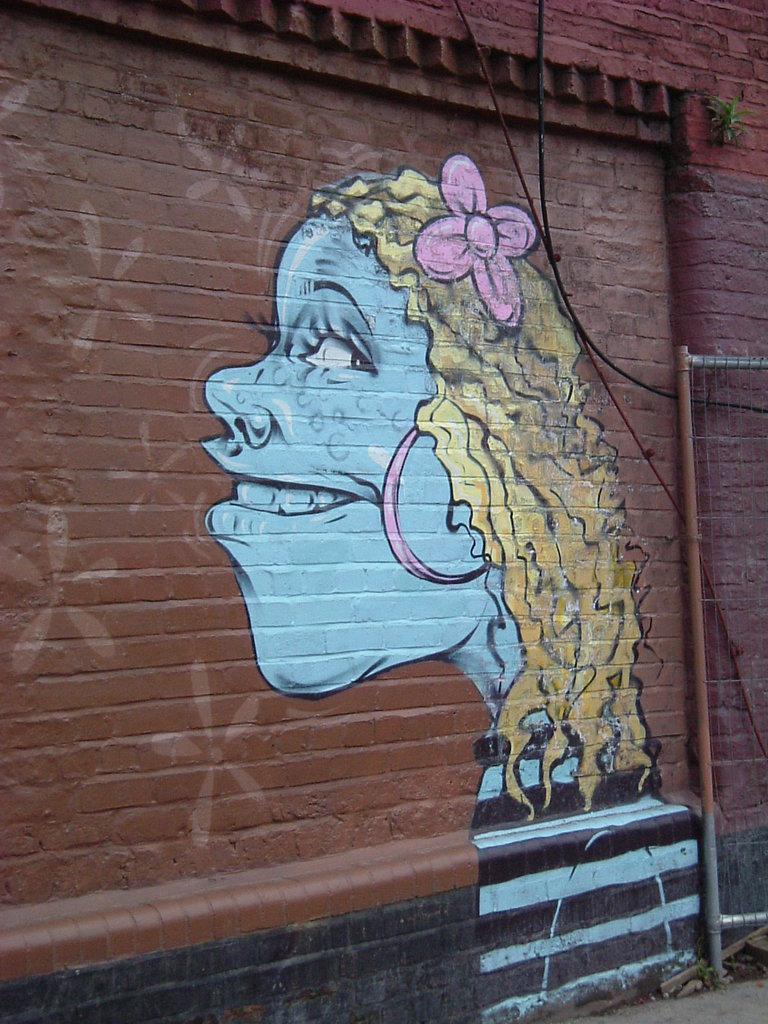Please provide a concise description of this image. In the image there is a graffiti of a girl on the wall. 